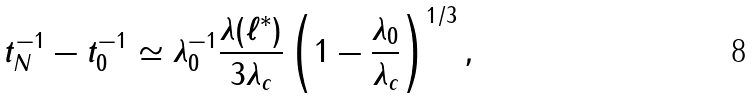<formula> <loc_0><loc_0><loc_500><loc_500>t _ { N } ^ { - 1 } - t _ { 0 } ^ { - 1 } \simeq \lambda _ { 0 } ^ { - 1 } \frac { \lambda ( \ell ^ { \ast } ) } { 3 \lambda _ { c } } \left ( 1 - \frac { \lambda _ { 0 } } { \lambda _ { c } } \right ) ^ { 1 / 3 } ,</formula> 